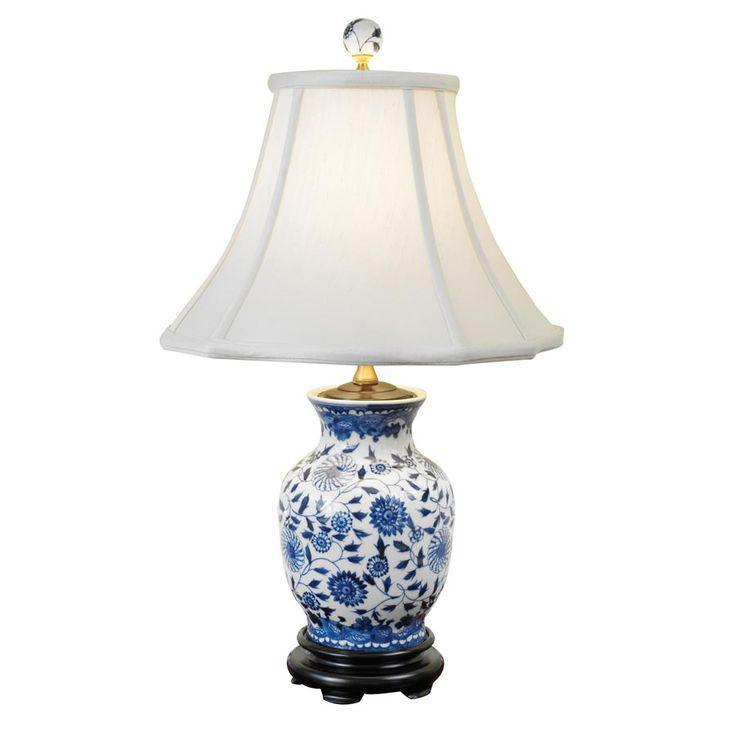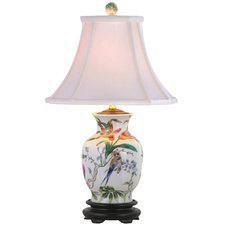The first image is the image on the left, the second image is the image on the right. Evaluate the accuracy of this statement regarding the images: "The ceramic base of the lamp on the right has a fuller top and tapers toward the bottom, and the base of the lamp on the left is decorated with a bird and flowers and has a dark footed bottom.". Is it true? Answer yes or no. No. The first image is the image on the left, the second image is the image on the right. Examine the images to the left and right. Is the description "In at least one image there is a  white porcelain lamp with two birds facing each other  etched in to the base." accurate? Answer yes or no. No. 